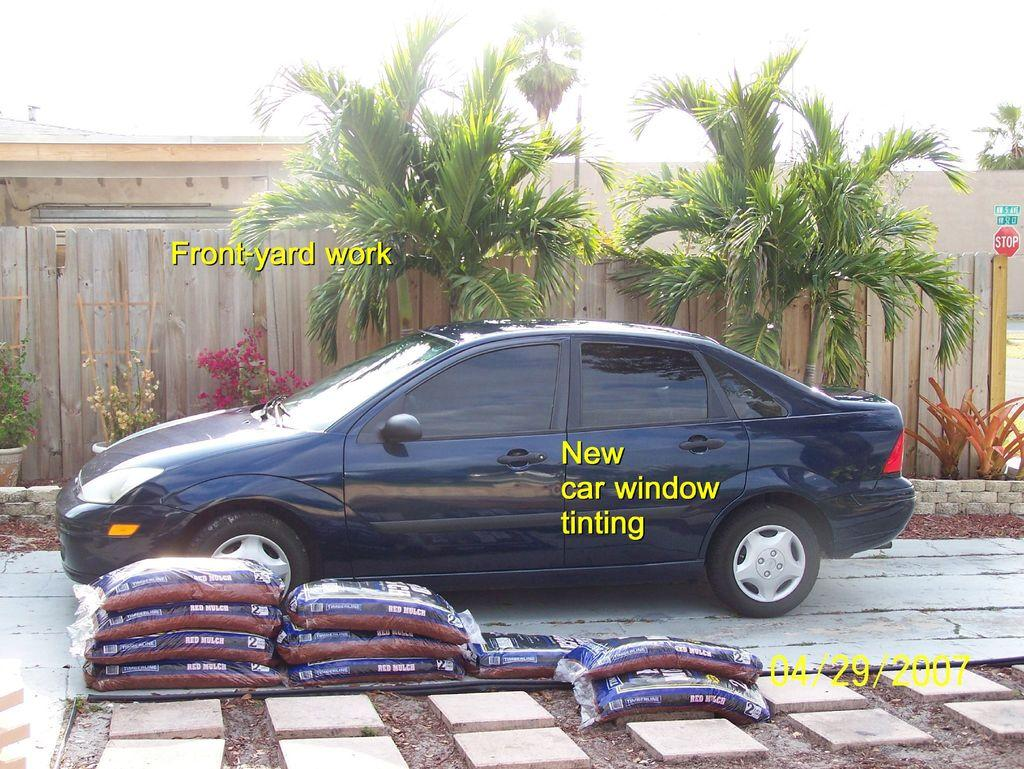Provide a one-sentence caption for the provided image. A dark blue car that has just had its windows tinted. 